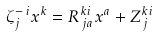Convert formula to latex. <formula><loc_0><loc_0><loc_500><loc_500>\zeta ^ { - \, i } _ { j } x ^ { k } = R ^ { k i } _ { \, j a } x ^ { a } + Z ^ { k i } _ { \, j }</formula> 